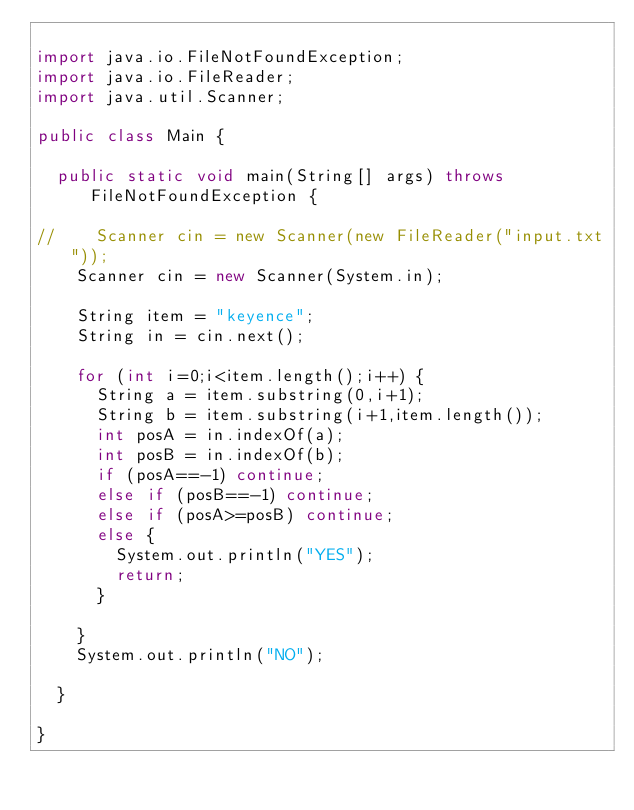<code> <loc_0><loc_0><loc_500><loc_500><_Java_>
import java.io.FileNotFoundException;
import java.io.FileReader;
import java.util.Scanner;

public class Main {

  public static void main(String[] args) throws FileNotFoundException {

//    Scanner cin = new Scanner(new FileReader("input.txt"));
    Scanner cin = new Scanner(System.in);

    String item = "keyence";
    String in = cin.next();

    for (int i=0;i<item.length();i++) {
      String a = item.substring(0,i+1);
      String b = item.substring(i+1,item.length());
      int posA = in.indexOf(a);
      int posB = in.indexOf(b);
      if (posA==-1) continue;
      else if (posB==-1) continue;
      else if (posA>=posB) continue;
      else {
        System.out.println("YES");
        return;
      }

    }
    System.out.println("NO");

  }

}
</code> 